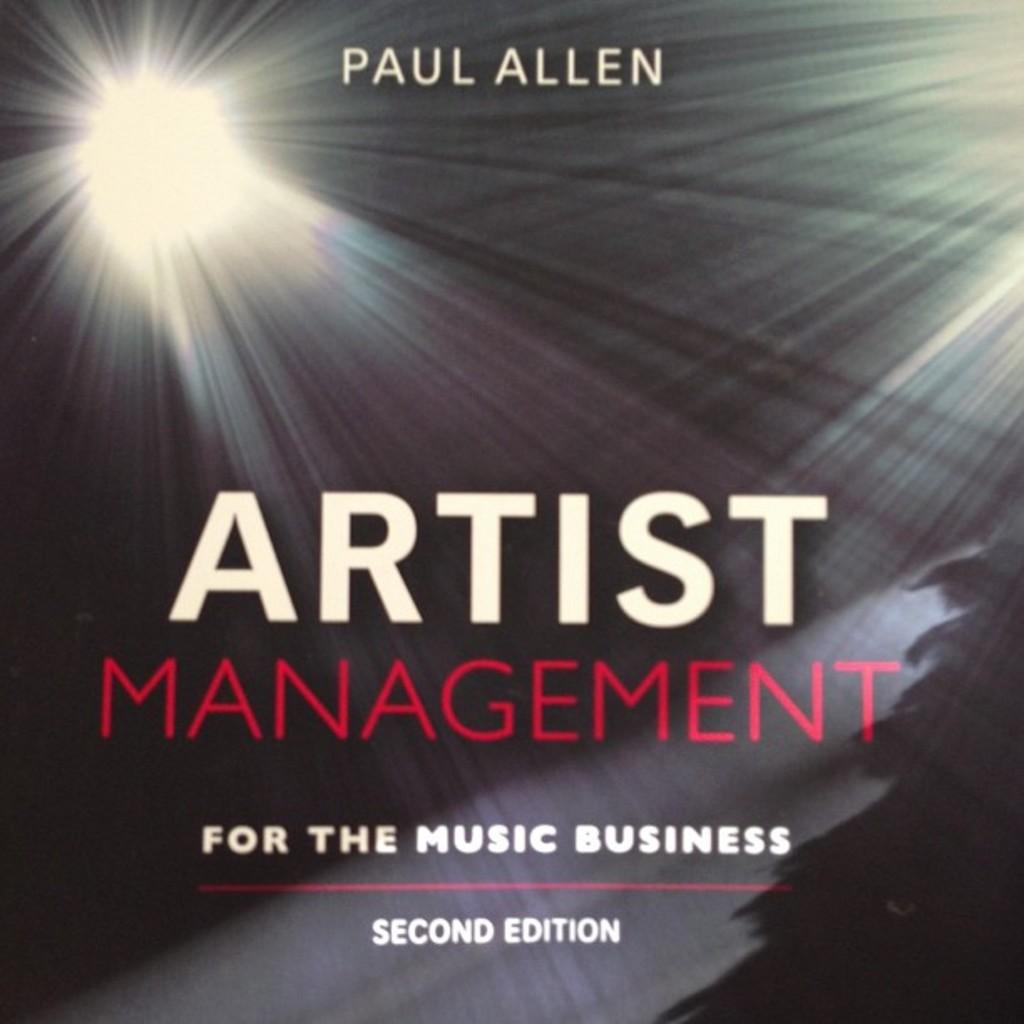<image>
Write a terse but informative summary of the picture. A book, titled Artist Management for the Music Business, was written by Paul Allen. 